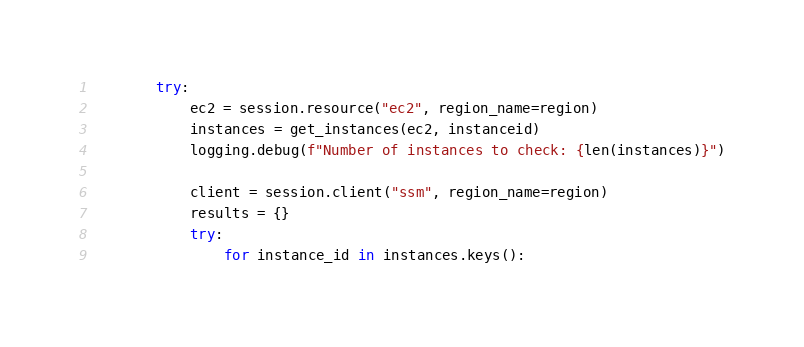Convert code to text. <code><loc_0><loc_0><loc_500><loc_500><_Python_>        try:
            ec2 = session.resource("ec2", region_name=region)
            instances = get_instances(ec2, instanceid)
            logging.debug(f"Number of instances to check: {len(instances)}")

            client = session.client("ssm", region_name=region)
            results = {}
            try:
                for instance_id in instances.keys():</code> 